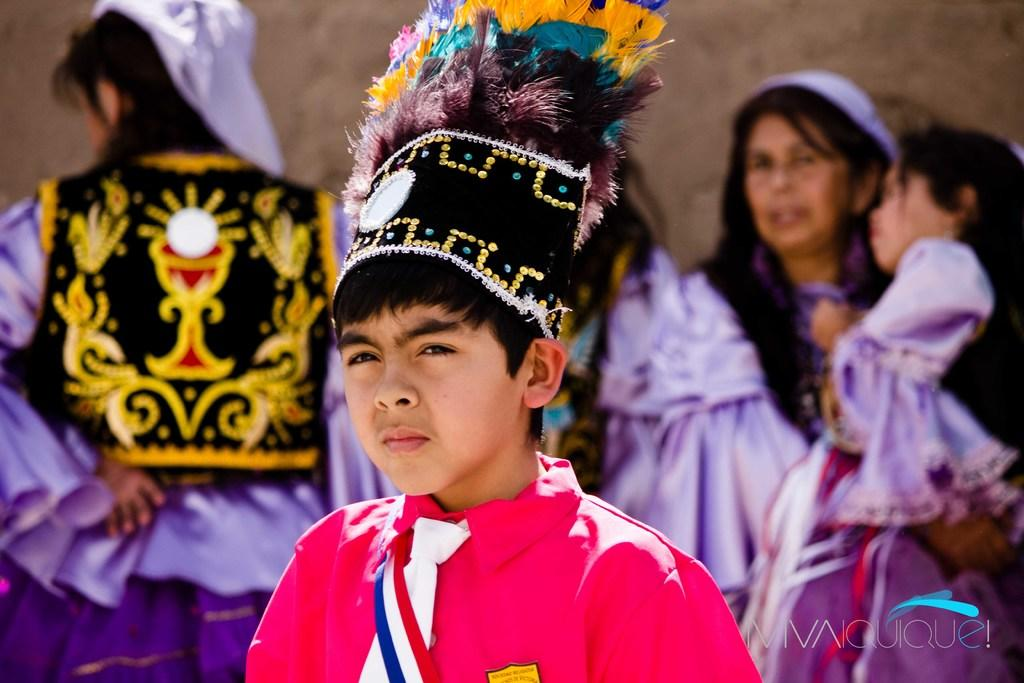What can be seen in the image? There are people standing in the image. What are the people wearing? The people are wearing clothes. What is the background of the image? There is a wall in the image. What is the income level of the people in the image? There is no information about the income level of the people in the image. 